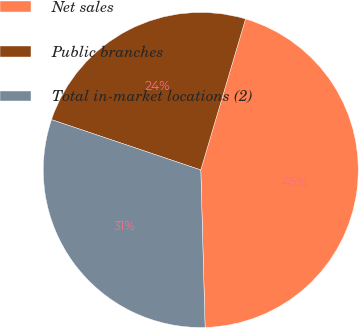<chart> <loc_0><loc_0><loc_500><loc_500><pie_chart><fcel>Net sales<fcel>Public branches<fcel>Total in-market locations (2)<nl><fcel>44.98%<fcel>24.41%<fcel>30.61%<nl></chart> 